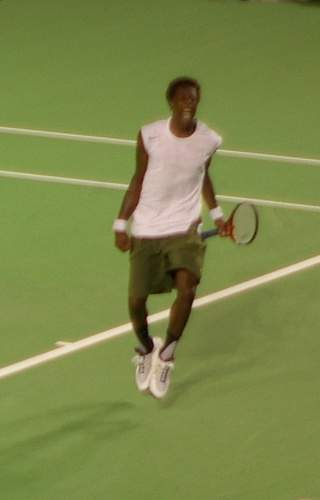Describe the objects in this image and their specific colors. I can see people in darkgreen, darkgray, maroon, black, and olive tones and tennis racket in darkgreen, olive, and maroon tones in this image. 